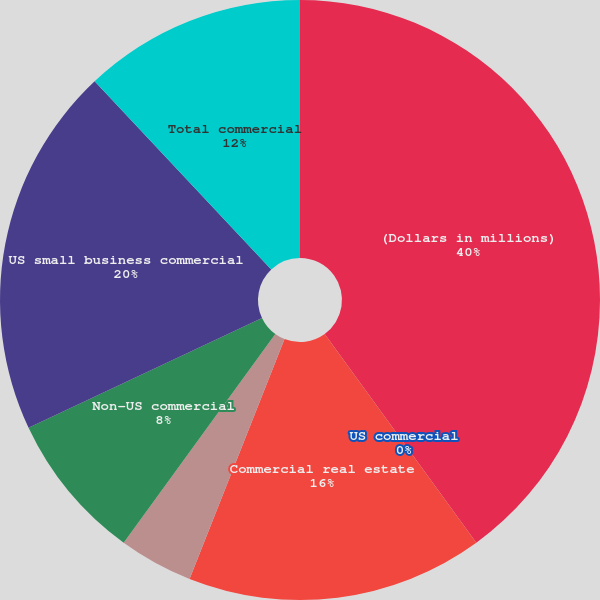<chart> <loc_0><loc_0><loc_500><loc_500><pie_chart><fcel>(Dollars in millions)<fcel>US commercial<fcel>Commercial real estate<fcel>Commercial lease financing<fcel>Non-US commercial<fcel>US small business commercial<fcel>Total commercial<nl><fcel>40.0%<fcel>0.0%<fcel>16.0%<fcel>4.0%<fcel>8.0%<fcel>20.0%<fcel>12.0%<nl></chart> 